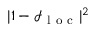Convert formula to latex. <formula><loc_0><loc_0><loc_500><loc_500>| 1 - \mathcal { I } _ { l o c } | ^ { 2 }</formula> 